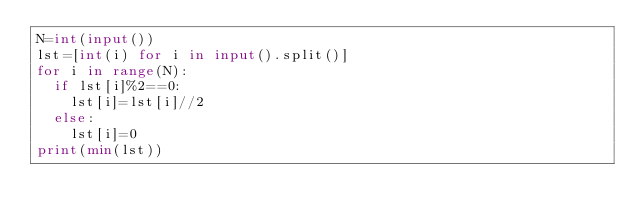<code> <loc_0><loc_0><loc_500><loc_500><_Python_>N=int(input())
lst=[int(i) for i in input().split()]
for i in range(N):
  if lst[i]%2==0:
    lst[i]=lst[i]//2
  else:
    lst[i]=0
print(min(lst))
  
</code> 